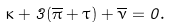<formula> <loc_0><loc_0><loc_500><loc_500>\kappa + 3 ( \overline { \pi } + \tau ) + \overline { \nu } = 0 .</formula> 